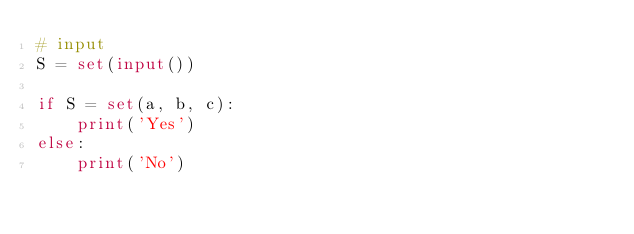Convert code to text. <code><loc_0><loc_0><loc_500><loc_500><_Python_># input
S = set(input())

if S = set(a, b, c):
    print('Yes')
else:
    print('No')</code> 